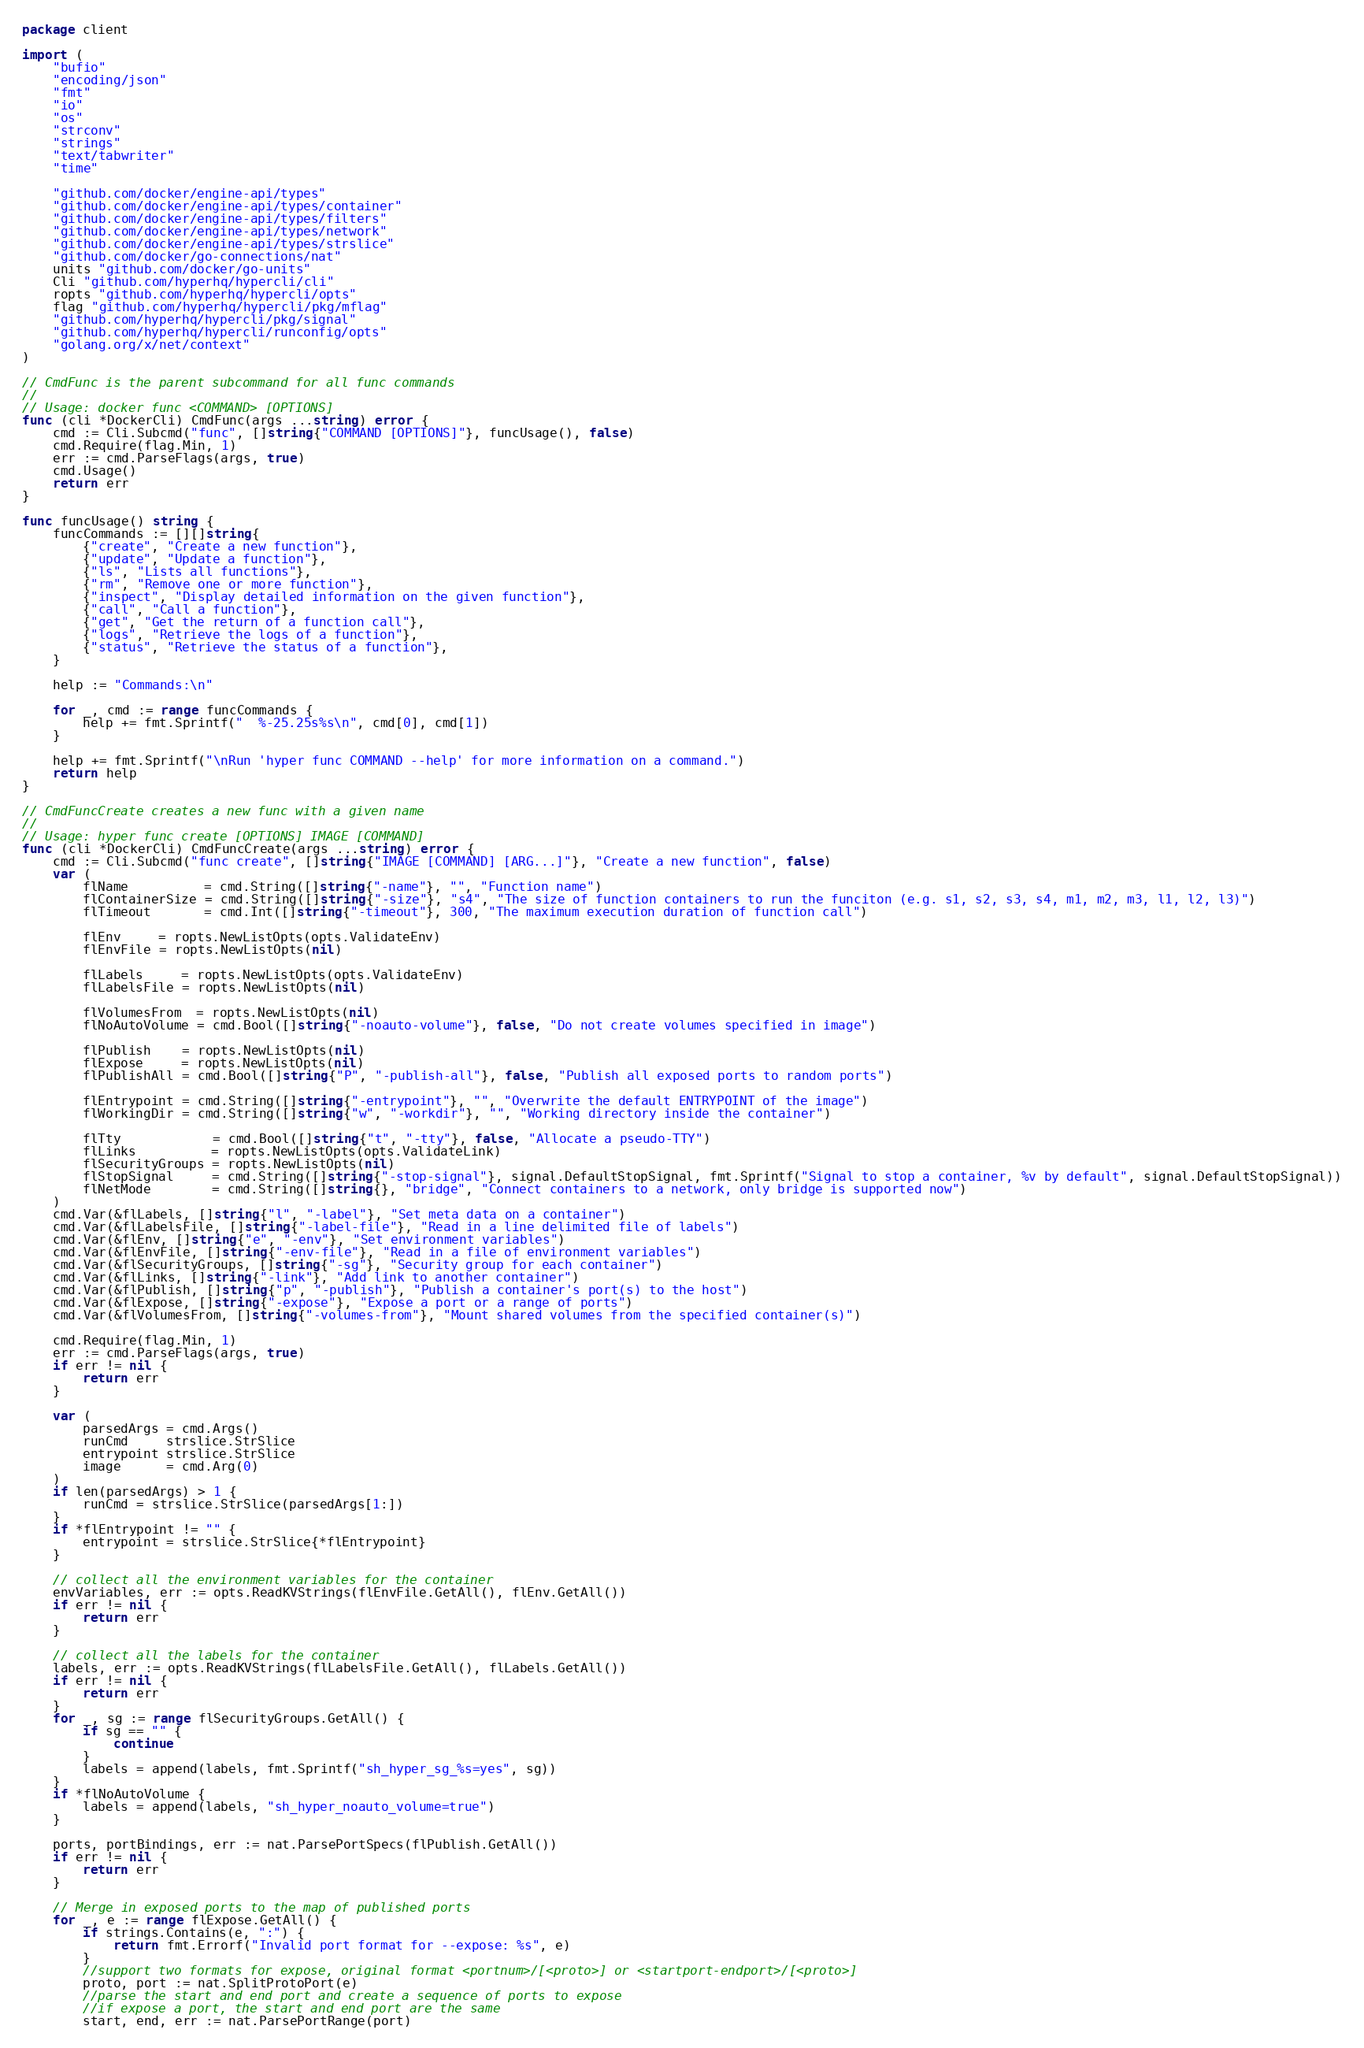<code> <loc_0><loc_0><loc_500><loc_500><_Go_>package client

import (
	"bufio"
	"encoding/json"
	"fmt"
	"io"
	"os"
	"strconv"
	"strings"
	"text/tabwriter"
	"time"

	"github.com/docker/engine-api/types"
	"github.com/docker/engine-api/types/container"
	"github.com/docker/engine-api/types/filters"
	"github.com/docker/engine-api/types/network"
	"github.com/docker/engine-api/types/strslice"
	"github.com/docker/go-connections/nat"
	units "github.com/docker/go-units"
	Cli "github.com/hyperhq/hypercli/cli"
	ropts "github.com/hyperhq/hypercli/opts"
	flag "github.com/hyperhq/hypercli/pkg/mflag"
	"github.com/hyperhq/hypercli/pkg/signal"
	"github.com/hyperhq/hypercli/runconfig/opts"
	"golang.org/x/net/context"
)

// CmdFunc is the parent subcommand for all func commands
//
// Usage: docker func <COMMAND> [OPTIONS]
func (cli *DockerCli) CmdFunc(args ...string) error {
	cmd := Cli.Subcmd("func", []string{"COMMAND [OPTIONS]"}, funcUsage(), false)
	cmd.Require(flag.Min, 1)
	err := cmd.ParseFlags(args, true)
	cmd.Usage()
	return err
}

func funcUsage() string {
	funcCommands := [][]string{
		{"create", "Create a new function"},
		{"update", "Update a function"},
		{"ls", "Lists all functions"},
		{"rm", "Remove one or more function"},
		{"inspect", "Display detailed information on the given function"},
		{"call", "Call a function"},
		{"get", "Get the return of a function call"},
		{"logs", "Retrieve the logs of a function"},
		{"status", "Retrieve the status of a function"},
	}

	help := "Commands:\n"

	for _, cmd := range funcCommands {
		help += fmt.Sprintf("  %-25.25s%s\n", cmd[0], cmd[1])
	}

	help += fmt.Sprintf("\nRun 'hyper func COMMAND --help' for more information on a command.")
	return help
}

// CmdFuncCreate creates a new func with a given name
//
// Usage: hyper func create [OPTIONS] IMAGE [COMMAND]
func (cli *DockerCli) CmdFuncCreate(args ...string) error {
	cmd := Cli.Subcmd("func create", []string{"IMAGE [COMMAND] [ARG...]"}, "Create a new function", false)
	var (
		flName          = cmd.String([]string{"-name"}, "", "Function name")
		flContainerSize = cmd.String([]string{"-size"}, "s4", "The size of function containers to run the funciton (e.g. s1, s2, s3, s4, m1, m2, m3, l1, l2, l3)")
		flTimeout       = cmd.Int([]string{"-timeout"}, 300, "The maximum execution duration of function call")

		flEnv     = ropts.NewListOpts(opts.ValidateEnv)
		flEnvFile = ropts.NewListOpts(nil)

		flLabels     = ropts.NewListOpts(opts.ValidateEnv)
		flLabelsFile = ropts.NewListOpts(nil)

		flVolumesFrom  = ropts.NewListOpts(nil)
		flNoAutoVolume = cmd.Bool([]string{"-noauto-volume"}, false, "Do not create volumes specified in image")

		flPublish    = ropts.NewListOpts(nil)
		flExpose     = ropts.NewListOpts(nil)
		flPublishAll = cmd.Bool([]string{"P", "-publish-all"}, false, "Publish all exposed ports to random ports")

		flEntrypoint = cmd.String([]string{"-entrypoint"}, "", "Overwrite the default ENTRYPOINT of the image")
		flWorkingDir = cmd.String([]string{"w", "-workdir"}, "", "Working directory inside the container")

		flTty            = cmd.Bool([]string{"t", "-tty"}, false, "Allocate a pseudo-TTY")
		flLinks          = ropts.NewListOpts(opts.ValidateLink)
		flSecurityGroups = ropts.NewListOpts(nil)
		flStopSignal     = cmd.String([]string{"-stop-signal"}, signal.DefaultStopSignal, fmt.Sprintf("Signal to stop a container, %v by default", signal.DefaultStopSignal))
		flNetMode        = cmd.String([]string{}, "bridge", "Connect containers to a network, only bridge is supported now")
	)
	cmd.Var(&flLabels, []string{"l", "-label"}, "Set meta data on a container")
	cmd.Var(&flLabelsFile, []string{"-label-file"}, "Read in a line delimited file of labels")
	cmd.Var(&flEnv, []string{"e", "-env"}, "Set environment variables")
	cmd.Var(&flEnvFile, []string{"-env-file"}, "Read in a file of environment variables")
	cmd.Var(&flSecurityGroups, []string{"-sg"}, "Security group for each container")
	cmd.Var(&flLinks, []string{"-link"}, "Add link to another container")
	cmd.Var(&flPublish, []string{"p", "-publish"}, "Publish a container's port(s) to the host")
	cmd.Var(&flExpose, []string{"-expose"}, "Expose a port or a range of ports")
	cmd.Var(&flVolumesFrom, []string{"-volumes-from"}, "Mount shared volumes from the specified container(s)")

	cmd.Require(flag.Min, 1)
	err := cmd.ParseFlags(args, true)
	if err != nil {
		return err
	}

	var (
		parsedArgs = cmd.Args()
		runCmd     strslice.StrSlice
		entrypoint strslice.StrSlice
		image      = cmd.Arg(0)
	)
	if len(parsedArgs) > 1 {
		runCmd = strslice.StrSlice(parsedArgs[1:])
	}
	if *flEntrypoint != "" {
		entrypoint = strslice.StrSlice{*flEntrypoint}
	}

	// collect all the environment variables for the container
	envVariables, err := opts.ReadKVStrings(flEnvFile.GetAll(), flEnv.GetAll())
	if err != nil {
		return err
	}

	// collect all the labels for the container
	labels, err := opts.ReadKVStrings(flLabelsFile.GetAll(), flLabels.GetAll())
	if err != nil {
		return err
	}
	for _, sg := range flSecurityGroups.GetAll() {
		if sg == "" {
			continue
		}
		labels = append(labels, fmt.Sprintf("sh_hyper_sg_%s=yes", sg))
	}
	if *flNoAutoVolume {
		labels = append(labels, "sh_hyper_noauto_volume=true")
	}

	ports, portBindings, err := nat.ParsePortSpecs(flPublish.GetAll())
	if err != nil {
		return err
	}

	// Merge in exposed ports to the map of published ports
	for _, e := range flExpose.GetAll() {
		if strings.Contains(e, ":") {
			return fmt.Errorf("Invalid port format for --expose: %s", e)
		}
		//support two formats for expose, original format <portnum>/[<proto>] or <startport-endport>/[<proto>]
		proto, port := nat.SplitProtoPort(e)
		//parse the start and end port and create a sequence of ports to expose
		//if expose a port, the start and end port are the same
		start, end, err := nat.ParsePortRange(port)</code> 